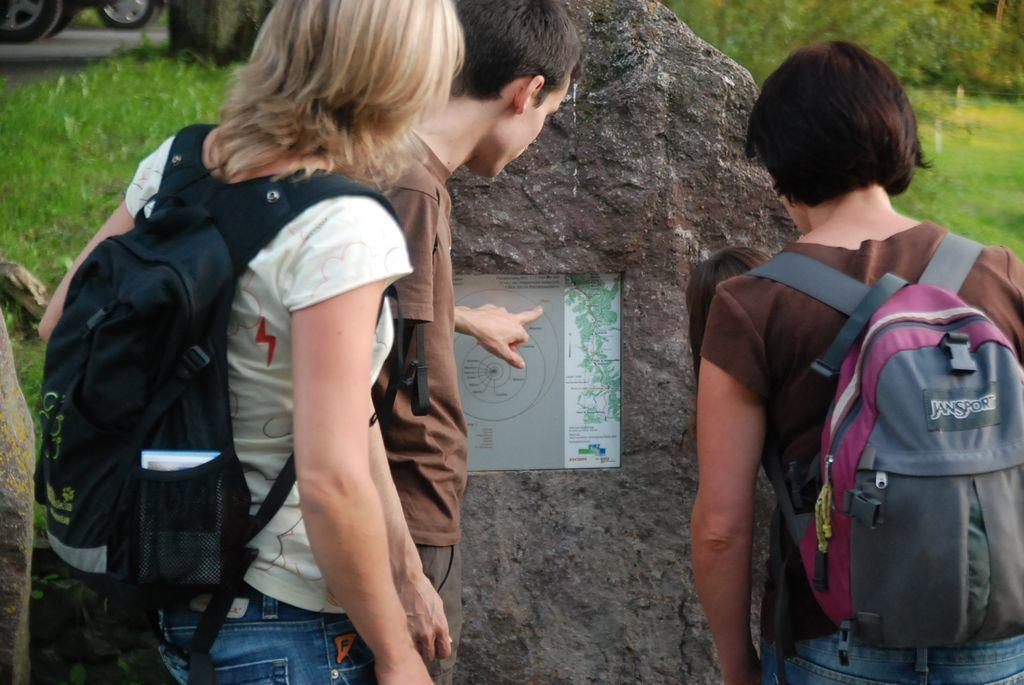Who or what is present in the image? There are people in the image. What are the people doing in the image? The people are standing. What are the people carrying in the image? The people are carrying backpacks. How many chickens can be seen in the image? There are no chickens present in the image. What type of car is visible in the image? There are no cars present in the image. 